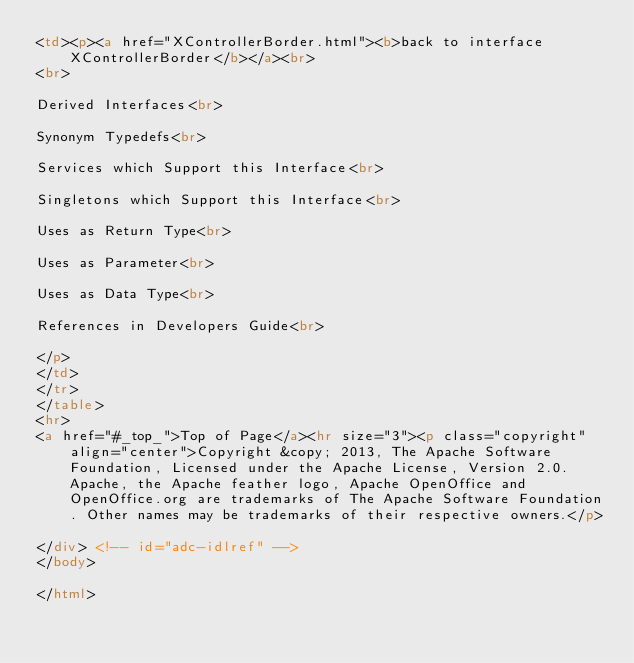Convert code to text. <code><loc_0><loc_0><loc_500><loc_500><_HTML_><td><p><a href="XControllerBorder.html"><b>back to interface XControllerBorder</b></a><br>
<br>

Derived Interfaces<br>

Synonym Typedefs<br>

Services which Support this Interface<br>

Singletons which Support this Interface<br>

Uses as Return Type<br>

Uses as Parameter<br>

Uses as Data Type<br>

References in Developers Guide<br>

</p>
</td>
</tr>
</table>
<hr>
<a href="#_top_">Top of Page</a><hr size="3"><p class="copyright" align="center">Copyright &copy; 2013, The Apache Software Foundation, Licensed under the Apache License, Version 2.0. Apache, the Apache feather logo, Apache OpenOffice and OpenOffice.org are trademarks of The Apache Software Foundation. Other names may be trademarks of their respective owners.</p>

</div> <!-- id="adc-idlref" -->
</body>

</html>
</code> 